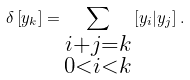Convert formula to latex. <formula><loc_0><loc_0><loc_500><loc_500>\delta \left [ y _ { k } \right ] = \sum _ { \substack { i + j = k \\ 0 < i < k } } \left [ y _ { i } | y _ { j } \right ] .</formula> 